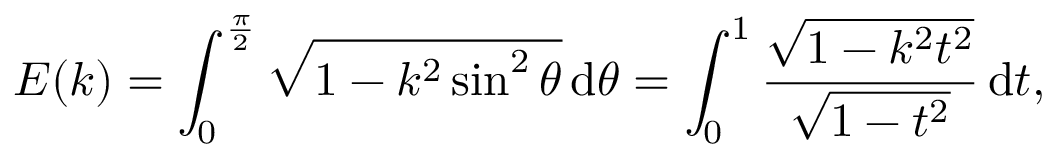<formula> <loc_0><loc_0><loc_500><loc_500>E ( k ) = \int _ { 0 } ^ { \frac { \pi } { 2 } } { \sqrt { 1 - k ^ { 2 } \sin ^ { 2 } \theta } } \, d \theta = \int _ { 0 } ^ { 1 } { \frac { \sqrt { 1 - k ^ { 2 } t ^ { 2 } } } { \sqrt { 1 - t ^ { 2 } } } } \, d t ,</formula> 